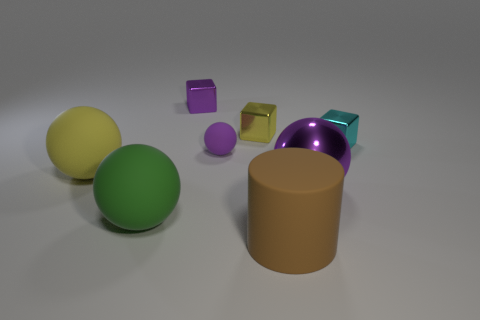Subtract all shiny balls. How many balls are left? 3 Subtract all yellow cubes. How many cubes are left? 2 Add 2 blue things. How many objects exist? 10 Subtract all cylinders. How many objects are left? 7 Subtract all red cubes. How many cyan spheres are left? 0 Subtract 0 red balls. How many objects are left? 8 Subtract all yellow cylinders. Subtract all cyan spheres. How many cylinders are left? 1 Subtract all large green objects. Subtract all small cyan balls. How many objects are left? 7 Add 8 big cylinders. How many big cylinders are left? 9 Add 1 small red matte cylinders. How many small red matte cylinders exist? 1 